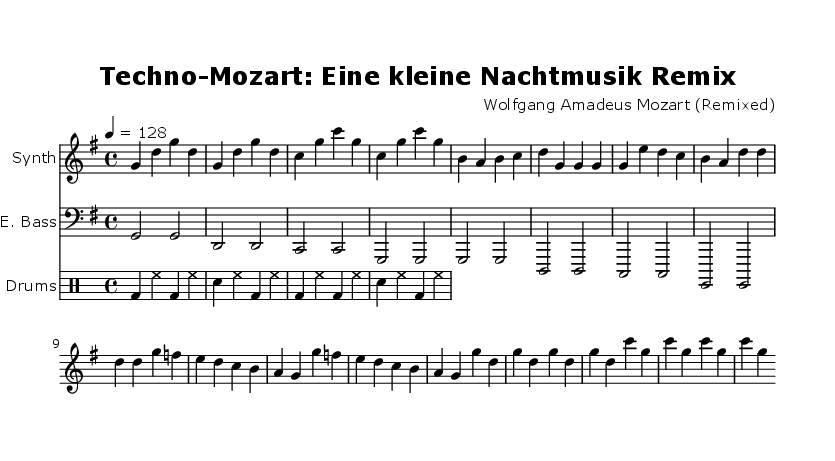What is the key signature of this music? The key signature is G major, which has one sharp (F#). This can be identified by looking at the key signature indicated at the beginning of the staff.
Answer: G major What is the time signature of this music? The time signature is 4/4, which is indicated at the beginning of the score with the two numbers stacked on top of each other. The upper number "4" represents the number of beats per measure, while the lower "4" indicates that a quarter note receives one beat.
Answer: 4/4 What is the tempo marking of this music? The tempo marking is 128 BPM, specified at the beginning of the score. The number indicates the beats per minute, providing a guideline for how fast the music should be played.
Answer: 128 How many measures are in the synthesizer part? The synthesizer part consists of 12 measures, which can be counted by looking at the distinct groups of notes separated by vertical lines (bar lines). Each group of notes between two bar lines represents one measure.
Answer: 12 What instruments are used in this remix? The instruments used in this remix are Synth, Electric Bass, and Drums. This can be determined by examining the instrument names specified at the beginning of each staff.
Answer: Synth, Electric Bass, Drums Which section of the music serves as the drop? The drop is the section that begins with the notes g' d g d and continues with the pattern. It can be identified by the change in dynamics and the rhythm that usually characterizes the drop in energetic dance music.
Answer: Drop What rhythmic pattern is present in the drum part? The rhythmic pattern in the drum part includes bass drums, snare, and hi-hat sounds. This is indicated in the drum section where different notations represent each drum sound, highlighting a consistent energetic beat.
Answer: Bass, snare, hi-hat 